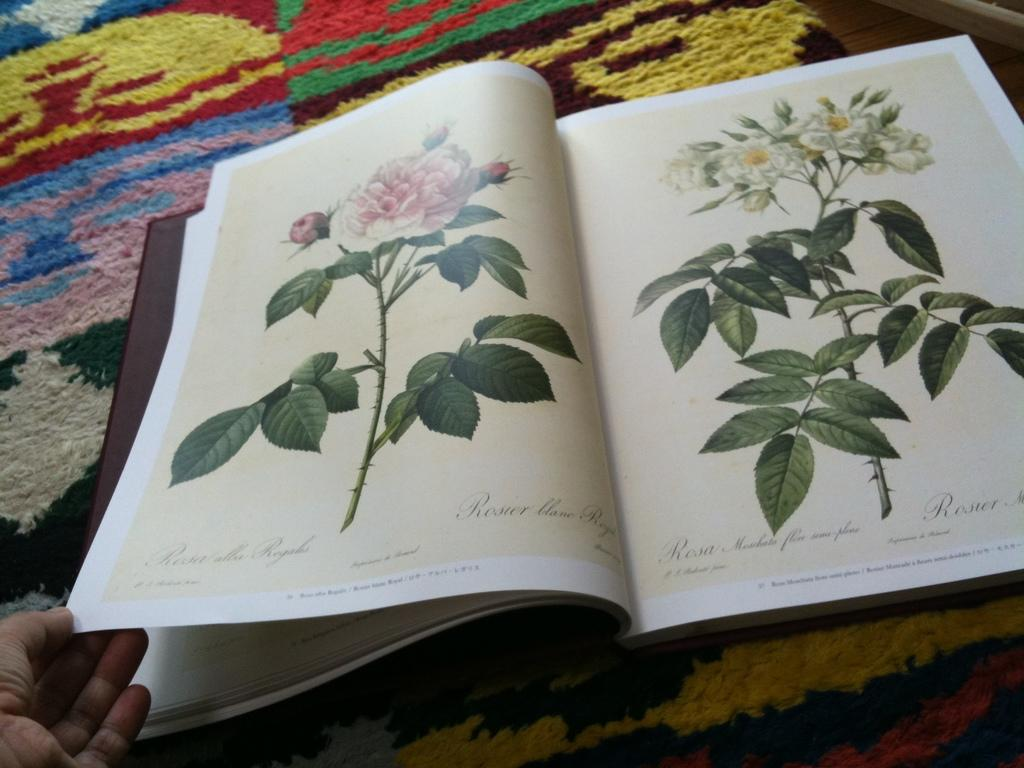<image>
Relay a brief, clear account of the picture shown. A book shows illustrations about species of roses. 